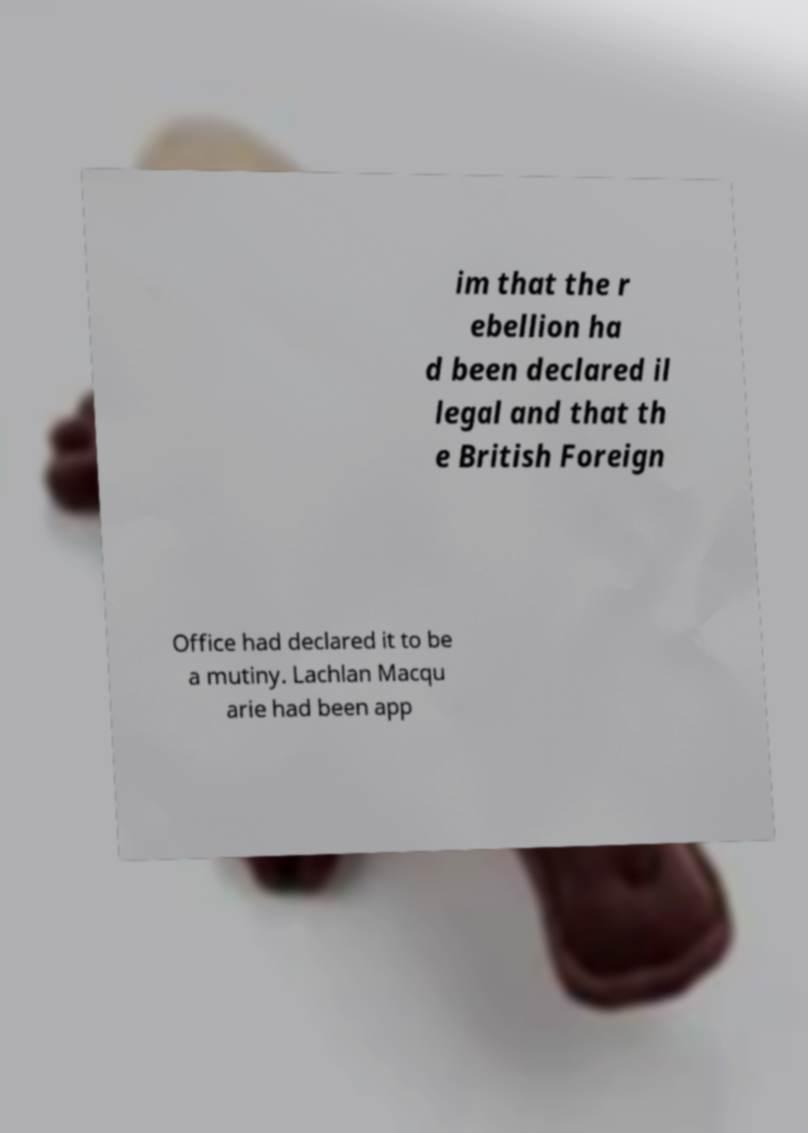What messages or text are displayed in this image? I need them in a readable, typed format. im that the r ebellion ha d been declared il legal and that th e British Foreign Office had declared it to be a mutiny. Lachlan Macqu arie had been app 